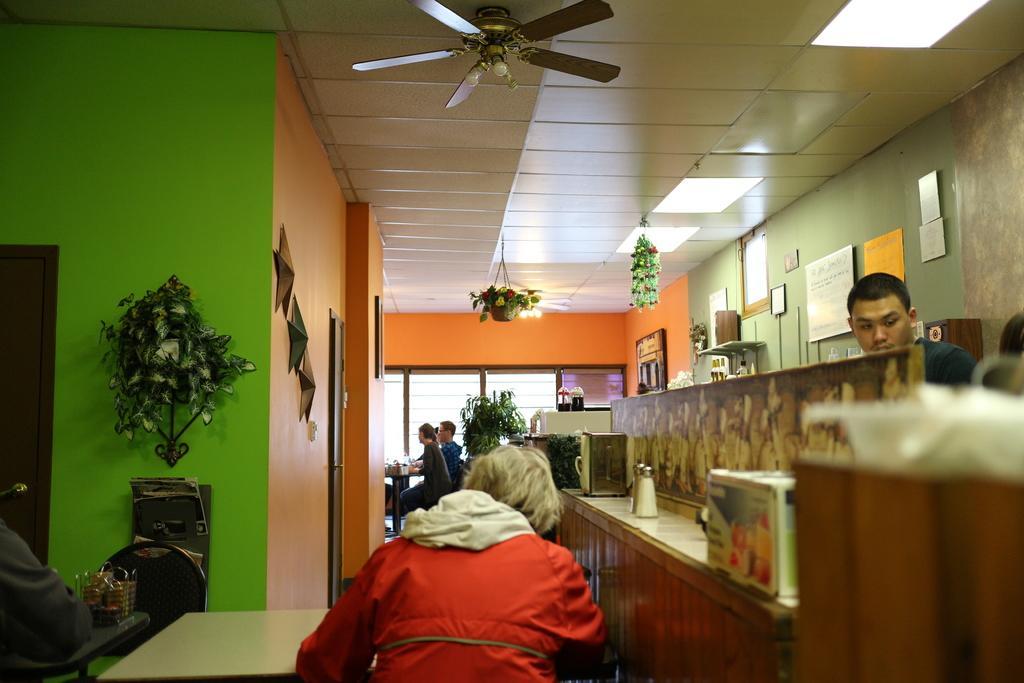Describe this image in one or two sentences. This picture describes about group of people few are seated on the chair and few are standing and we can see a plant, arts, and some paintings on the wall. On the top of them we can see a fan and couple of lights. 